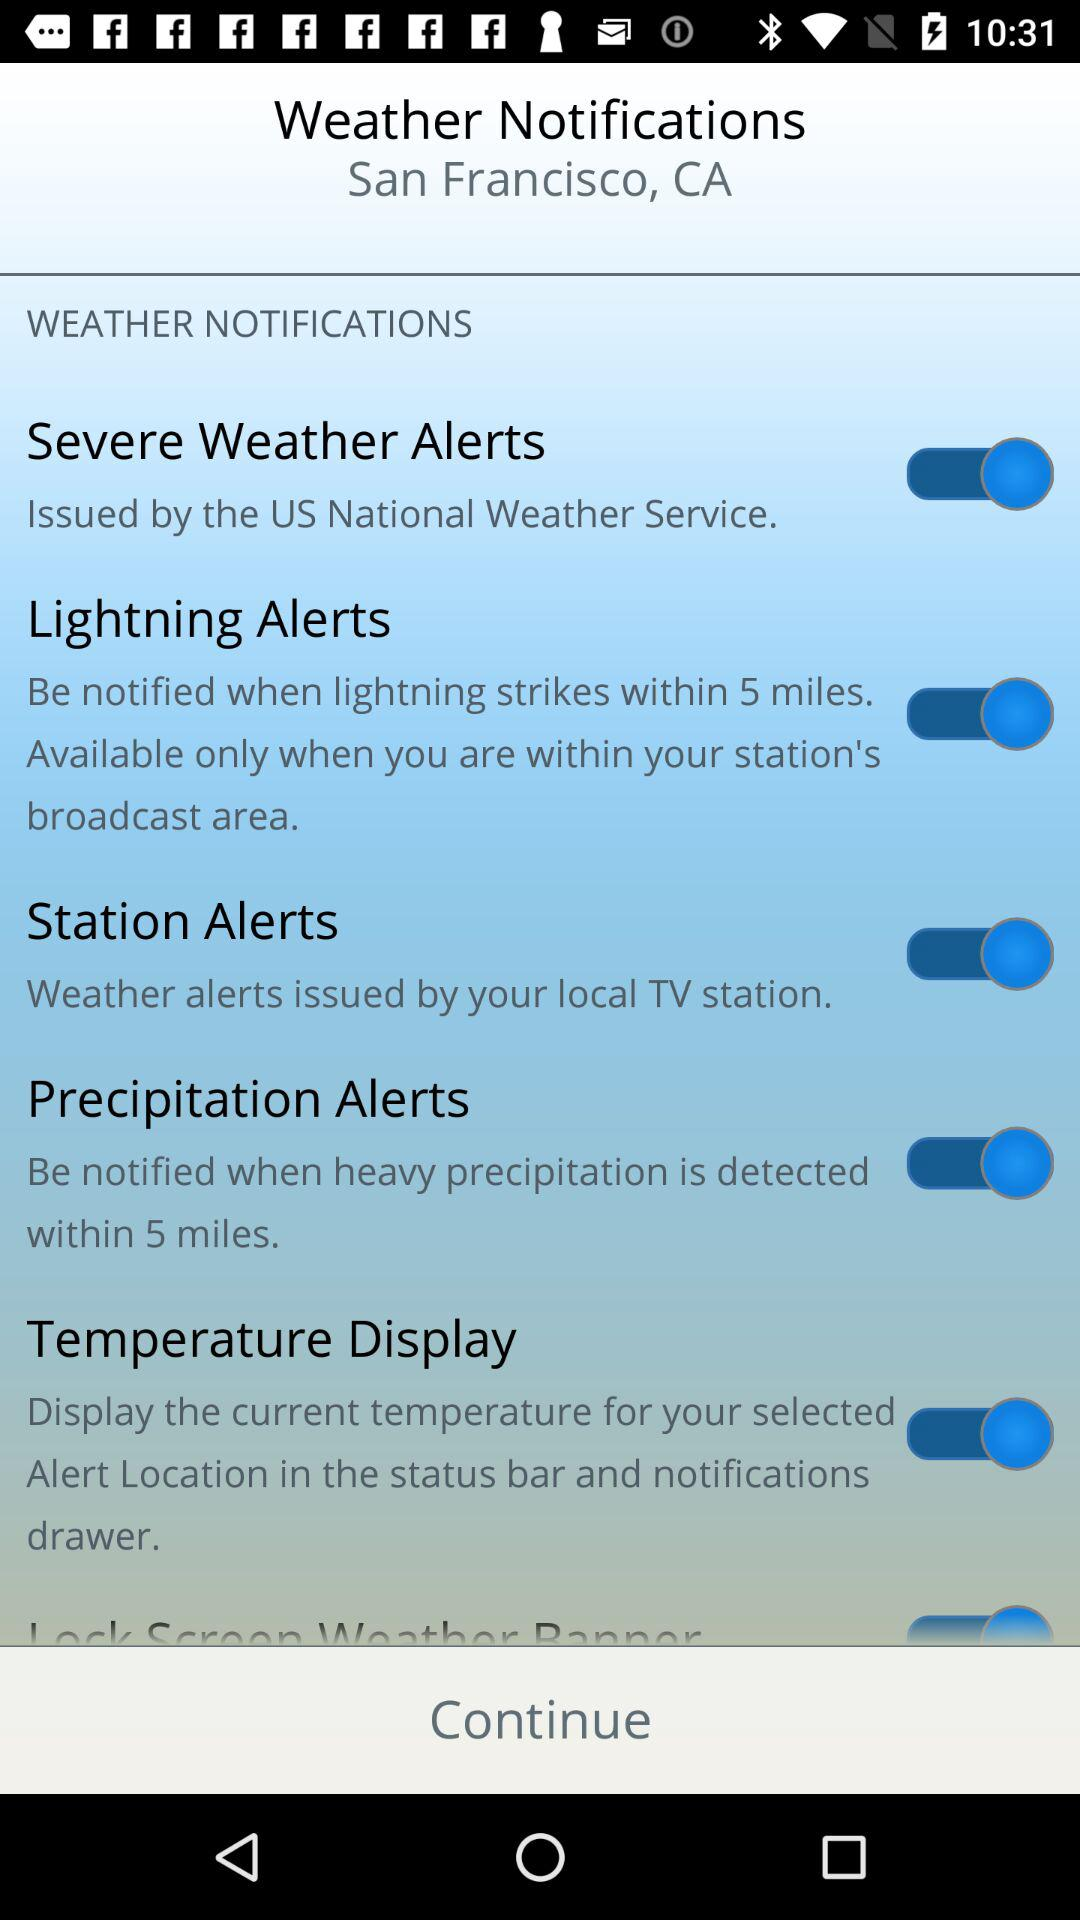By which service were severe weather alerts issued? Severe weather alerts were issued by "National Weather Service" of the US. 